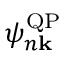<formula> <loc_0><loc_0><loc_500><loc_500>\psi _ { n k } ^ { Q P }</formula> 